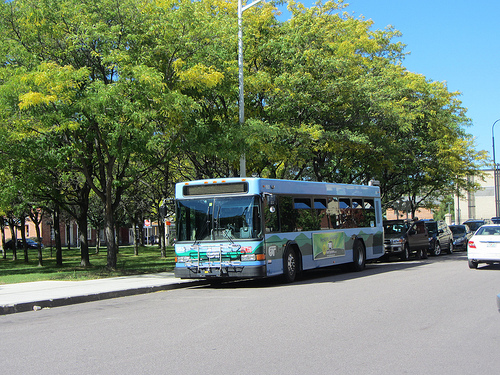Is the sky clear and blue? Yes, the sky is clear and has a bright blue color, indicating a sunny day. 